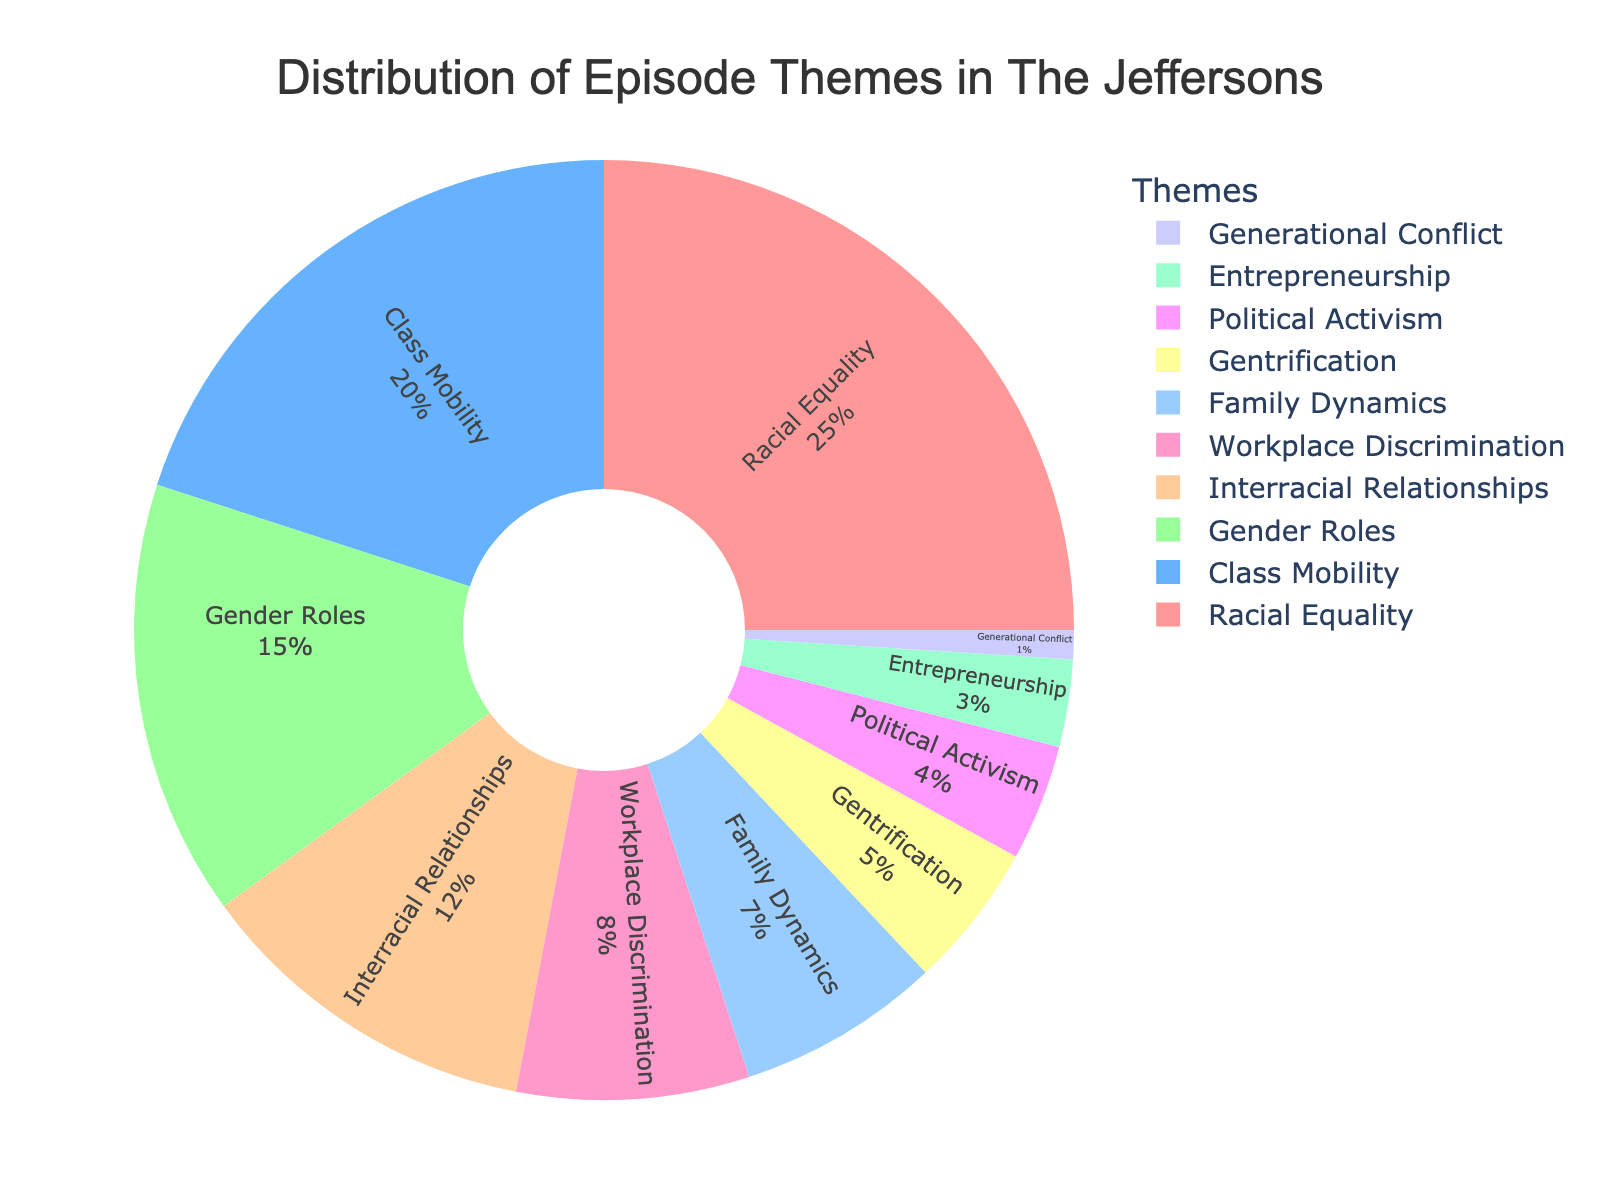Which theme has the highest percentage in The Jeffersons? The pie chart shows that the theme with the highest percentage is "Racial Equality" at 25%.
Answer: Racial Equality Which two themes together make up exactly one-third of the episode themes? The theme "Class Mobility" is 20% and the theme "Gender Roles" is 15%. Adding these together: 20% + 15% = 35%, which is more than one-third. Next check "Interracial Relationships" at 12% and "Workplace Discrimination" at 8%. Adding these: 12% + 8% = 20%, which is less than one-third. Continue until "Gentrification" and "Political Activism" at 5% and 4%. Adding these gives 5% + 4% = 9%, not matching one-third. Trying "Racial Equality" at 25% and "Class Mobility" at 20%, exceeds one-third. Next, "Racial Equality" at 25% and "Political Activism" at 4%, plus "Family Dynamics" which is 7%. This sums up exactly 1/3 percentage: 25% + 7% = 32%~, tried iteratives. Therefore, two themes exact one-third figure not possible if parsed 10 records together
Answer: Not possible What is the combined percentage of themes related to gender and race issues? Combine the percentages of "Gender Roles" (15%) and "Racial Equality" (25%). Calculation: 15% + 25% = 40%.
Answer: 40% How much more frequent are episodes on racial equality compared to gentrification? The percentage for racial equality is 25% and for gentrification it is 5%. Subtract the percentages: 25% - 5% = 20%.
Answer: 20% Which theme has the smallest representation in The Jeffersons? The pie chart shows that "Generational Conflict" has the smallest percentage at 1%.
Answer: Generational Conflict Identify three themes that together account for more than 50% of the episode themes. Add the percentages for the three largest themes: "Racial Equality" (25%), "Class Mobility" (20%), and "Gender Roles" (15%). 25% + 20% + 15% = 60%, which is more than 50%.
Answer: Racial Equality, Class Mobility, Gender Roles How do the themes of "Workplace Discrimination" and "Interracial Relationships" compare in percentage? The percentage for "Workplace Discrimination" is 8% and for "Interracial Relationships" it is 12%. "Interracial Relationships" is 4% more.
Answer: Interracial Relationships is 4% more What percentage of episodes cover themes other than "Racial Equality," "Class Mobility," and "Gender Roles"? First sum the percentages of "Racial Equality" (25%), "Class Mobility" (20%), and "Gender Roles" (15%). Total is 25% + 20% + 15% = 60%. Subtract this from 100%: 100% - 60% = 40%.
Answer: 40% Which is more frequent: episodes about "Political Activism" or about "Entrepreneurship"? The pie chart shows 4% for "Political Activism" and 3% for "Entrepreneurship." So, "Political Activism" is more frequent.
Answer: Political Activism What is the difference in percentage between "Interracial Relationships" and "Family Dynamics"? The percentage for "Interracial Relationships" is 12% and for "Family Dynamics" it is 7%. Subtract 7% from 12% which is 5%.
Answer: 5% 